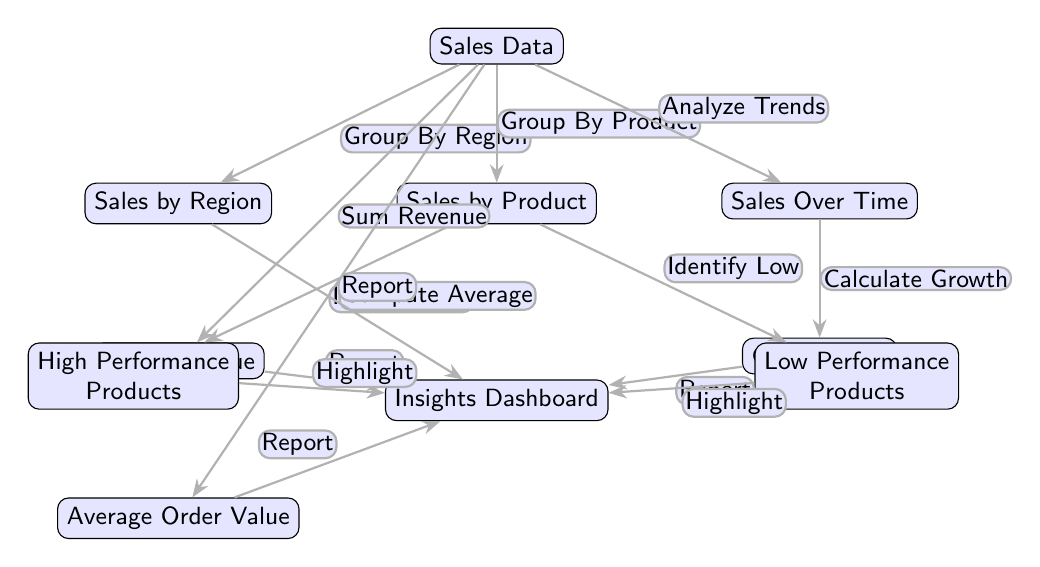What is the first node in the diagram? The first node is labeled "Sales Data," which is positioned at the top of the diagram. It's the source of all subsequent data processing.
Answer: Sales Data How many edges are connected to the "Sales Data" node? There are five edges connected to the "Sales Data" node, each leading to different nodes that represent various analyses and computations.
Answer: 5 What metric is calculated from "Sales Over Time"? The metric calculated from "Sales Over Time" is the "Growth Rate," as represented by the edge leading from "Sales Over Time" to "Growth Rate."
Answer: Growth Rate Which two nodes are identified from "Sales by Product"? The two nodes identified from "Sales by Product" are "High Performance Products" and "Low Performance Products," as shown by the edges originating from "Sales by Product."
Answer: High Performance Products, Low Performance Products What does the "Total Revenue" node report to? The "Total Revenue" node reports to the "Insights Dashboard," which is connected through an edge. This indicates that the total revenue metric is included in the insights presented on the dashboard.
Answer: Insights Dashboard What are the two computation types performed on "Sales Data"? The two computations performed on "Sales Data" are "Sum Revenue" and "Compute Average," indicating key operations that analyze overall sales performance.
Answer: Sum Revenue, Compute Average How is "Average Order Value" connected to the "Insights Dashboard"? "Average Order Value" is connected to the "Insights Dashboard" through an edge that indicates it is reported to the dashboard for insights visualization.
Answer: Report Which node is highlighted by the "Identify Low" process? The node highlighted by the "Identify Low" process is "Low Performance Products," showing that this analysis focuses on underperforming products.
Answer: Low Performance Products How is the "Sales by Region" node related to the "Insights Dashboard"? The "Sales by Region" node is related to the "Insights Dashboard" through a reporting edge, signifying that regional sales data is included in the insights provided.
Answer: Report 